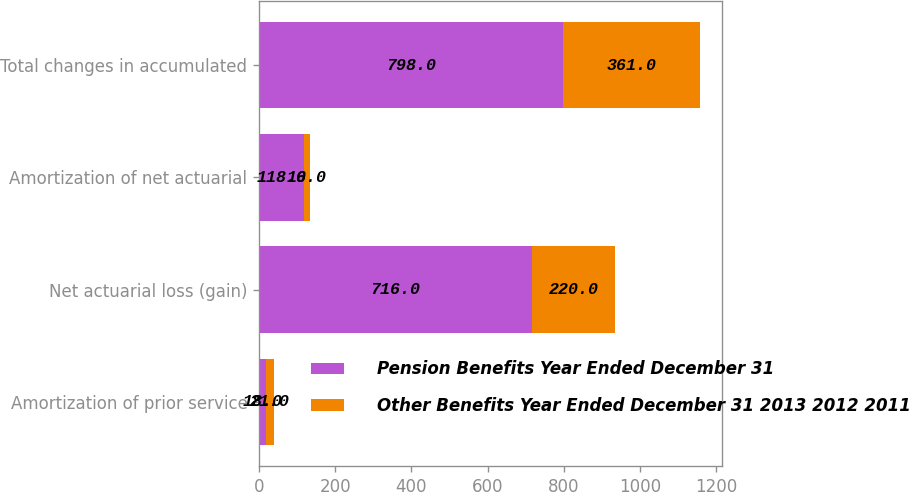<chart> <loc_0><loc_0><loc_500><loc_500><stacked_bar_chart><ecel><fcel>Amortization of prior service<fcel>Net actuarial loss (gain)<fcel>Amortization of net actuarial<fcel>Total changes in accumulated<nl><fcel>Pension Benefits Year Ended December 31<fcel>18<fcel>716<fcel>118<fcel>798<nl><fcel>Other Benefits Year Ended December 31 2013 2012 2011<fcel>21<fcel>220<fcel>16<fcel>361<nl></chart> 